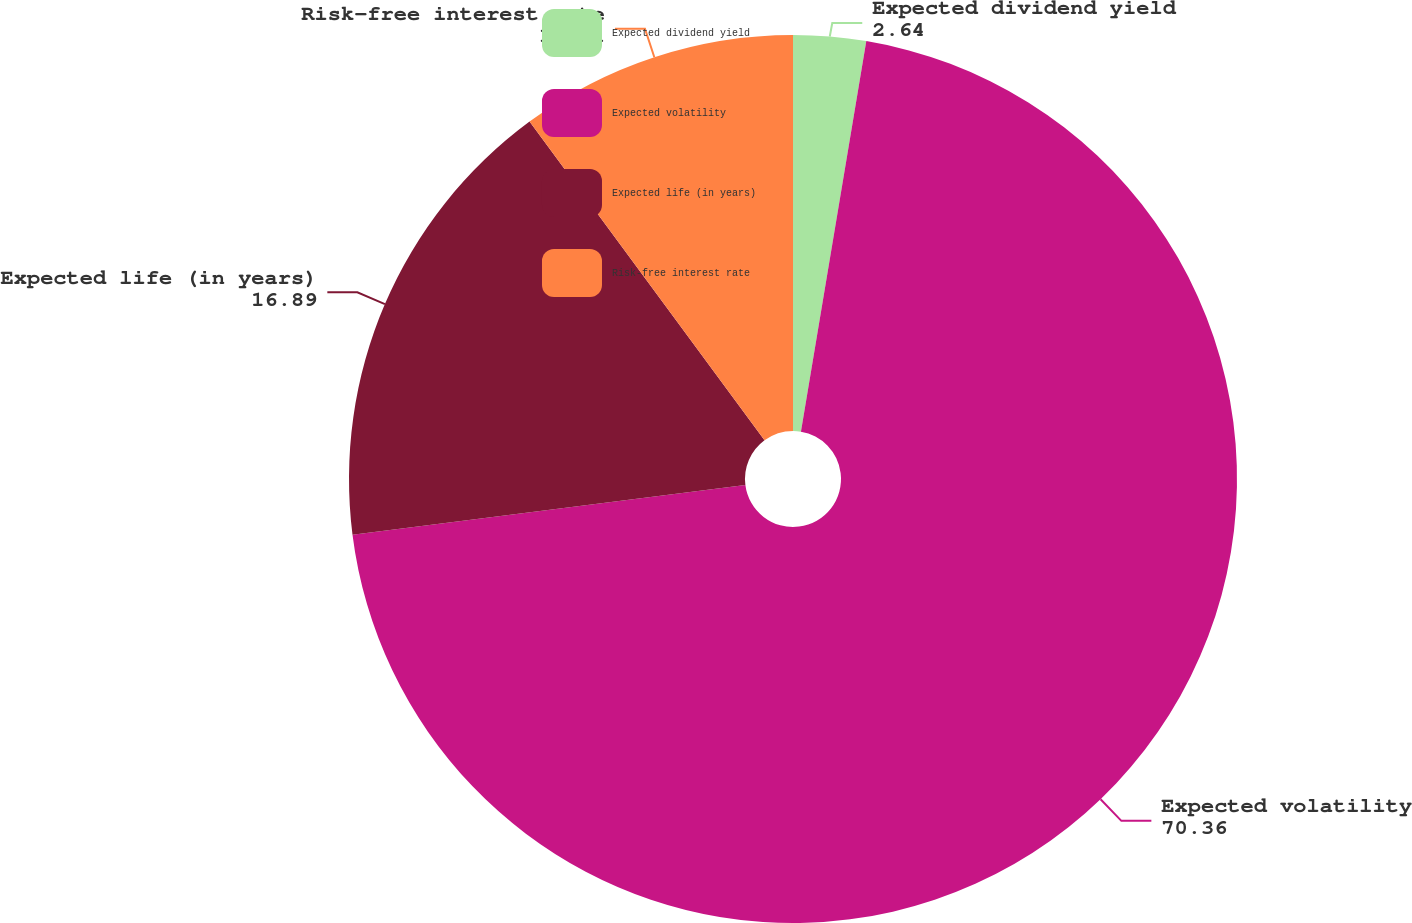<chart> <loc_0><loc_0><loc_500><loc_500><pie_chart><fcel>Expected dividend yield<fcel>Expected volatility<fcel>Expected life (in years)<fcel>Risk-free interest rate<nl><fcel>2.64%<fcel>70.36%<fcel>16.89%<fcel>10.11%<nl></chart> 